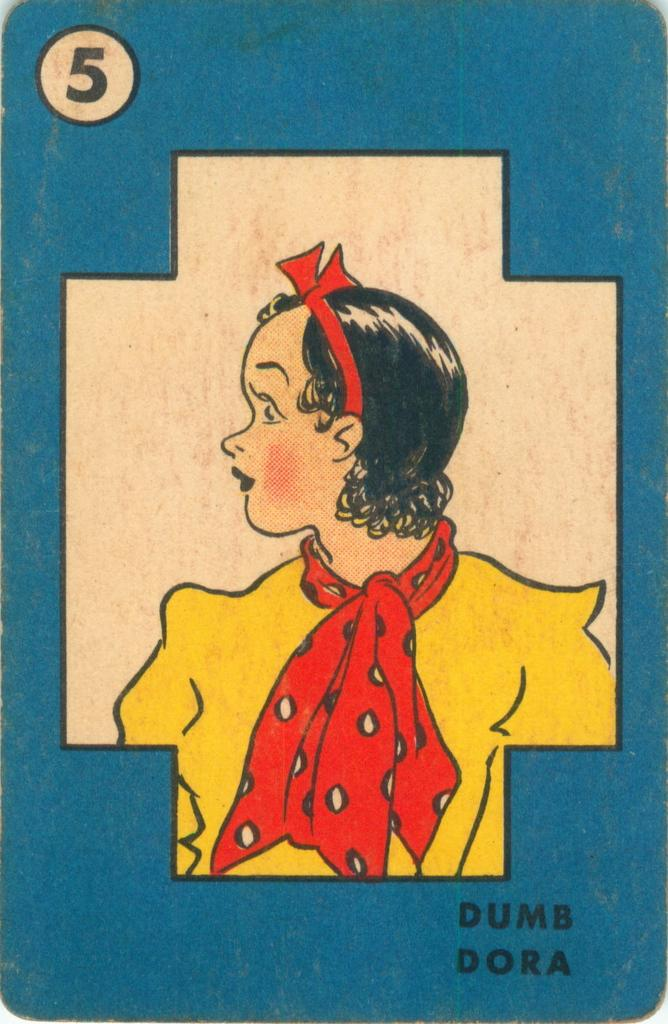What color is the object in the foreground of the image? The object in the foreground of the image is blue. What is depicted on the blue object? The blue object has a picture of a person wearing a yellow dress. Is there any text present in the image? Yes, there is text at the bottom of the image. What type of mint can be seen growing near the blue object in the image? There is no mint visible in the image; it only features a blue object with a picture of a person wearing a yellow dress and text at the bottom. 